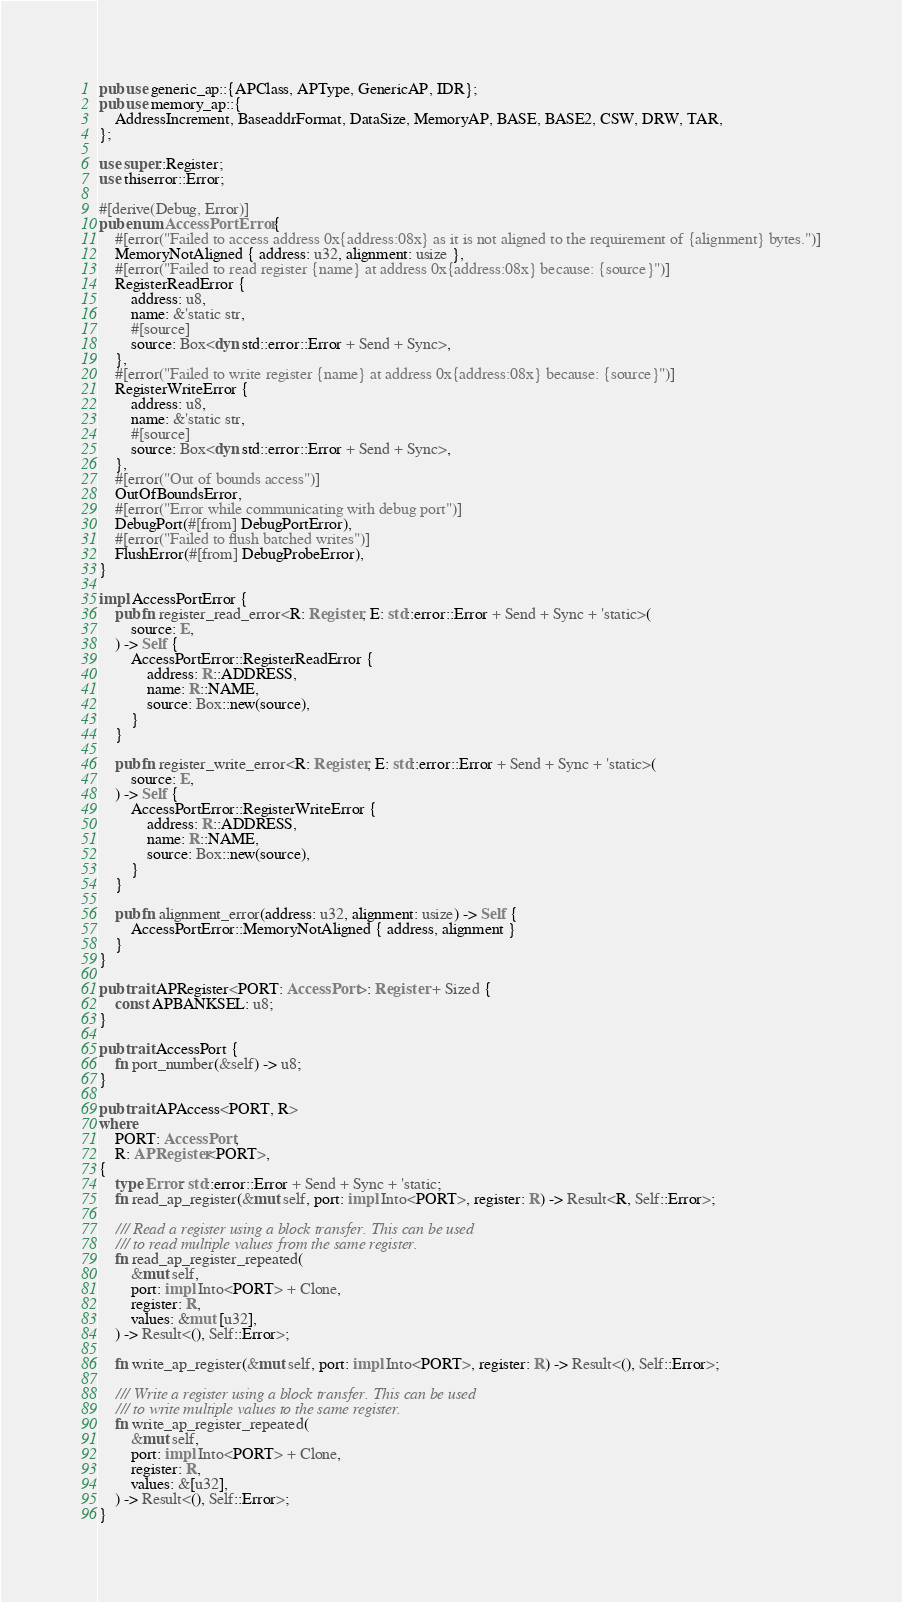Convert code to text. <code><loc_0><loc_0><loc_500><loc_500><_Rust_>pub use generic_ap::{APClass, APType, GenericAP, IDR};
pub use memory_ap::{
    AddressIncrement, BaseaddrFormat, DataSize, MemoryAP, BASE, BASE2, CSW, DRW, TAR,
};

use super::Register;
use thiserror::Error;

#[derive(Debug, Error)]
pub enum AccessPortError {
    #[error("Failed to access address 0x{address:08x} as it is not aligned to the requirement of {alignment} bytes.")]
    MemoryNotAligned { address: u32, alignment: usize },
    #[error("Failed to read register {name} at address 0x{address:08x} because: {source}")]
    RegisterReadError {
        address: u8,
        name: &'static str,
        #[source]
        source: Box<dyn std::error::Error + Send + Sync>,
    },
    #[error("Failed to write register {name} at address 0x{address:08x} because: {source}")]
    RegisterWriteError {
        address: u8,
        name: &'static str,
        #[source]
        source: Box<dyn std::error::Error + Send + Sync>,
    },
    #[error("Out of bounds access")]
    OutOfBoundsError,
    #[error("Error while communicating with debug port")]
    DebugPort(#[from] DebugPortError),
    #[error("Failed to flush batched writes")]
    FlushError(#[from] DebugProbeError),
}

impl AccessPortError {
    pub fn register_read_error<R: Register, E: std::error::Error + Send + Sync + 'static>(
        source: E,
    ) -> Self {
        AccessPortError::RegisterReadError {
            address: R::ADDRESS,
            name: R::NAME,
            source: Box::new(source),
        }
    }

    pub fn register_write_error<R: Register, E: std::error::Error + Send + Sync + 'static>(
        source: E,
    ) -> Self {
        AccessPortError::RegisterWriteError {
            address: R::ADDRESS,
            name: R::NAME,
            source: Box::new(source),
        }
    }

    pub fn alignment_error(address: u32, alignment: usize) -> Self {
        AccessPortError::MemoryNotAligned { address, alignment }
    }
}

pub trait APRegister<PORT: AccessPort>: Register + Sized {
    const APBANKSEL: u8;
}

pub trait AccessPort {
    fn port_number(&self) -> u8;
}

pub trait APAccess<PORT, R>
where
    PORT: AccessPort,
    R: APRegister<PORT>,
{
    type Error: std::error::Error + Send + Sync + 'static;
    fn read_ap_register(&mut self, port: impl Into<PORT>, register: R) -> Result<R, Self::Error>;

    /// Read a register using a block transfer. This can be used
    /// to read multiple values from the same register.
    fn read_ap_register_repeated(
        &mut self,
        port: impl Into<PORT> + Clone,
        register: R,
        values: &mut [u32],
    ) -> Result<(), Self::Error>;

    fn write_ap_register(&mut self, port: impl Into<PORT>, register: R) -> Result<(), Self::Error>;

    /// Write a register using a block transfer. This can be used
    /// to write multiple values to the same register.
    fn write_ap_register_repeated(
        &mut self,
        port: impl Into<PORT> + Clone,
        register: R,
        values: &[u32],
    ) -> Result<(), Self::Error>;
}
</code> 